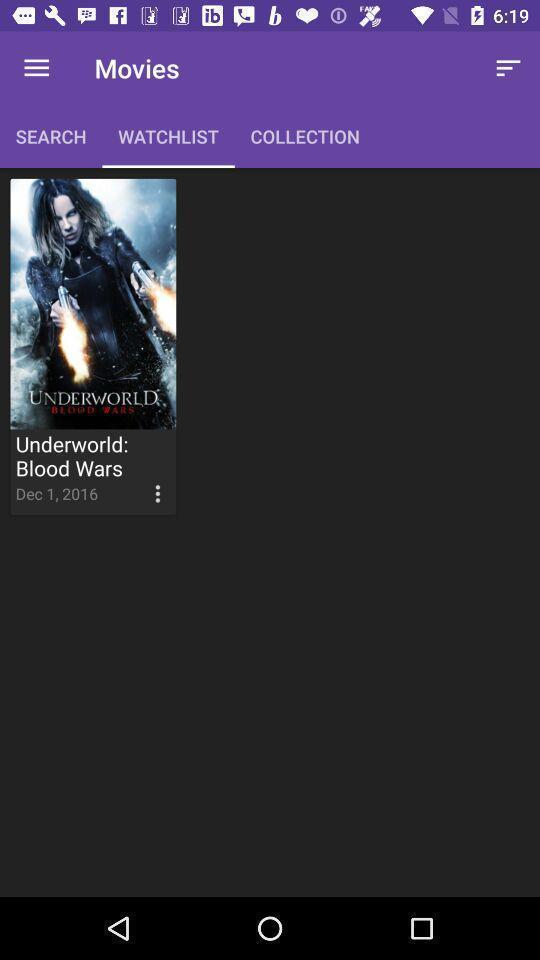Provide a description of this screenshot. Page showing your watchlist in the entertainment app. 